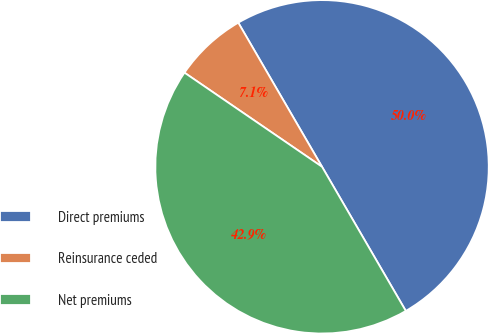Convert chart to OTSL. <chart><loc_0><loc_0><loc_500><loc_500><pie_chart><fcel>Direct premiums<fcel>Reinsurance ceded<fcel>Net premiums<nl><fcel>50.0%<fcel>7.07%<fcel>42.93%<nl></chart> 